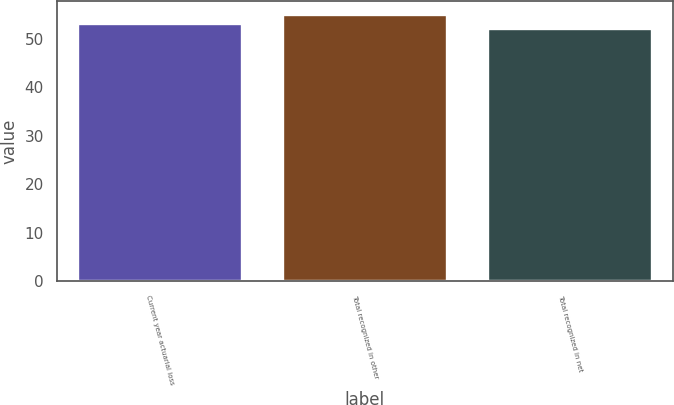Convert chart to OTSL. <chart><loc_0><loc_0><loc_500><loc_500><bar_chart><fcel>Current year actuarial loss<fcel>Total recognized in other<fcel>Total recognized in net<nl><fcel>53<fcel>55<fcel>52<nl></chart> 